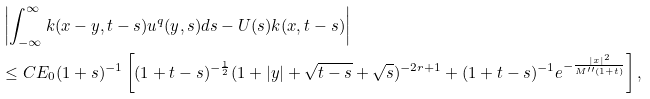Convert formula to latex. <formula><loc_0><loc_0><loc_500><loc_500>& \left | \int _ { - \infty } ^ { \infty } k ( x - y , t - s ) u ^ { q } ( y , s ) d s - U ( s ) k ( x , t - s ) \right | \\ & \leq C E _ { 0 } ( 1 + s ) ^ { - 1 } \left [ ( 1 + t - s ) ^ { - \frac { 1 } { 2 } } ( 1 + | y | + \sqrt { t - s } + \sqrt { s } ) ^ { - 2 r + 1 } + ( 1 + t - s ) ^ { - 1 } e ^ { - \frac { | x | ^ { 2 } } { M ^ { \prime \prime } ( 1 + t ) } } \right ] ,</formula> 